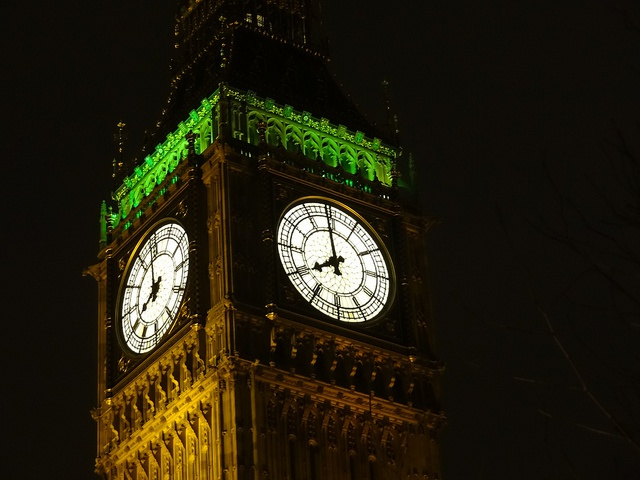Describe the objects in this image and their specific colors. I can see clock in black, ivory, darkgray, and gray tones and clock in black, ivory, beige, and darkgray tones in this image. 